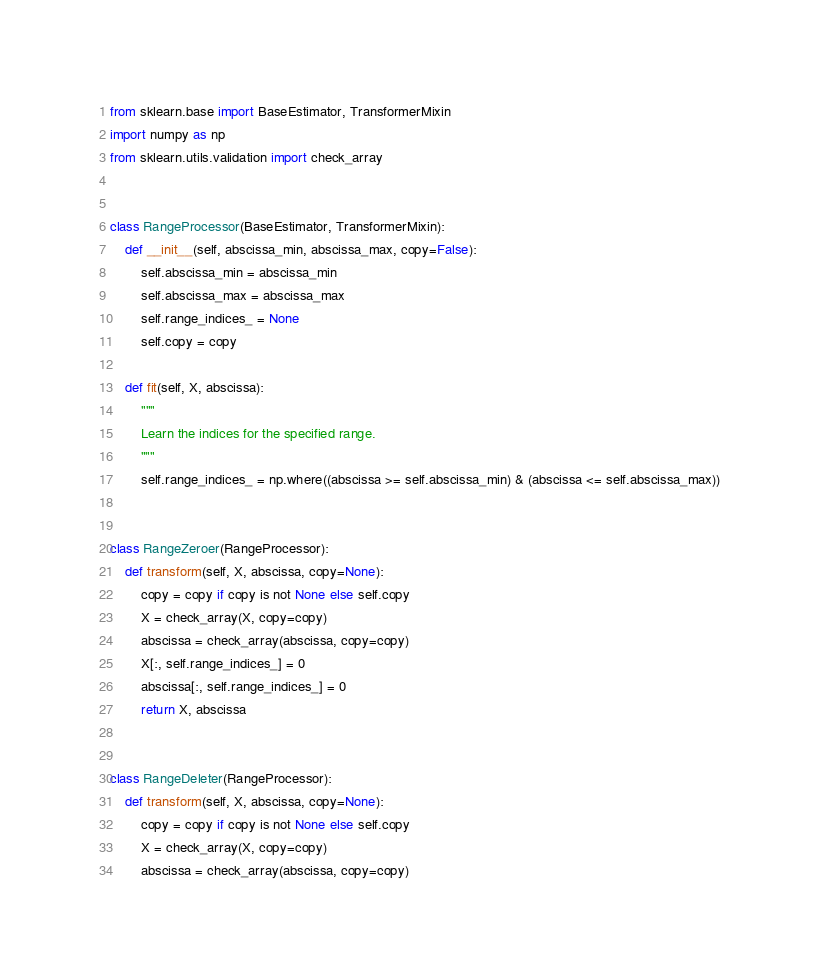<code> <loc_0><loc_0><loc_500><loc_500><_Python_>from sklearn.base import BaseEstimator, TransformerMixin
import numpy as np
from sklearn.utils.validation import check_array


class RangeProcessor(BaseEstimator, TransformerMixin):
    def __init__(self, abscissa_min, abscissa_max, copy=False):
        self.abscissa_min = abscissa_min
        self.abscissa_max = abscissa_max
        self.range_indices_ = None
        self.copy = copy

    def fit(self, X, abscissa):
        """
        Learn the indices for the specified range.
        """
        self.range_indices_ = np.where((abscissa >= self.abscissa_min) & (abscissa <= self.abscissa_max))


class RangeZeroer(RangeProcessor):
    def transform(self, X, abscissa, copy=None):
        copy = copy if copy is not None else self.copy
        X = check_array(X, copy=copy)
        abscissa = check_array(abscissa, copy=copy)
        X[:, self.range_indices_] = 0
        abscissa[:, self.range_indices_] = 0
        return X, abscissa


class RangeDeleter(RangeProcessor):
    def transform(self, X, abscissa, copy=None):
        copy = copy if copy is not None else self.copy
        X = check_array(X, copy=copy)
        abscissa = check_array(abscissa, copy=copy)</code> 